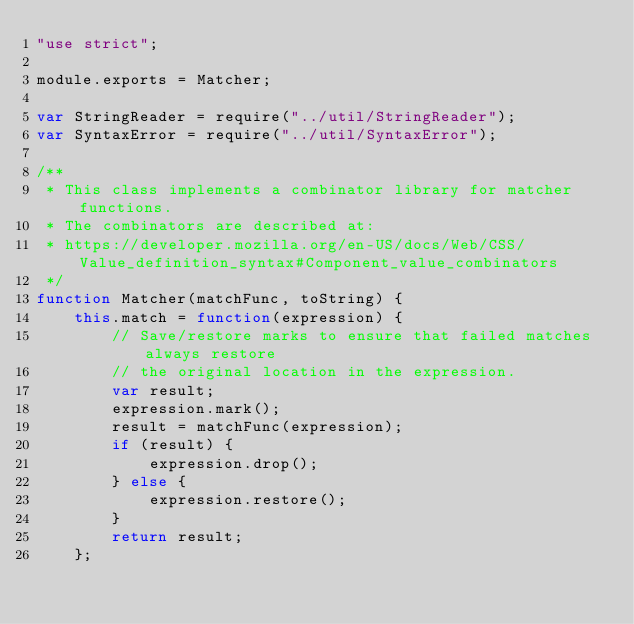Convert code to text. <code><loc_0><loc_0><loc_500><loc_500><_JavaScript_>"use strict";

module.exports = Matcher;

var StringReader = require("../util/StringReader");
var SyntaxError = require("../util/SyntaxError");

/**
 * This class implements a combinator library for matcher functions.
 * The combinators are described at:
 * https://developer.mozilla.org/en-US/docs/Web/CSS/Value_definition_syntax#Component_value_combinators
 */
function Matcher(matchFunc, toString) {
    this.match = function(expression) {
        // Save/restore marks to ensure that failed matches always restore
        // the original location in the expression.
        var result;
        expression.mark();
        result = matchFunc(expression);
        if (result) {
            expression.drop();
        } else {
            expression.restore();
        }
        return result;
    };</code> 